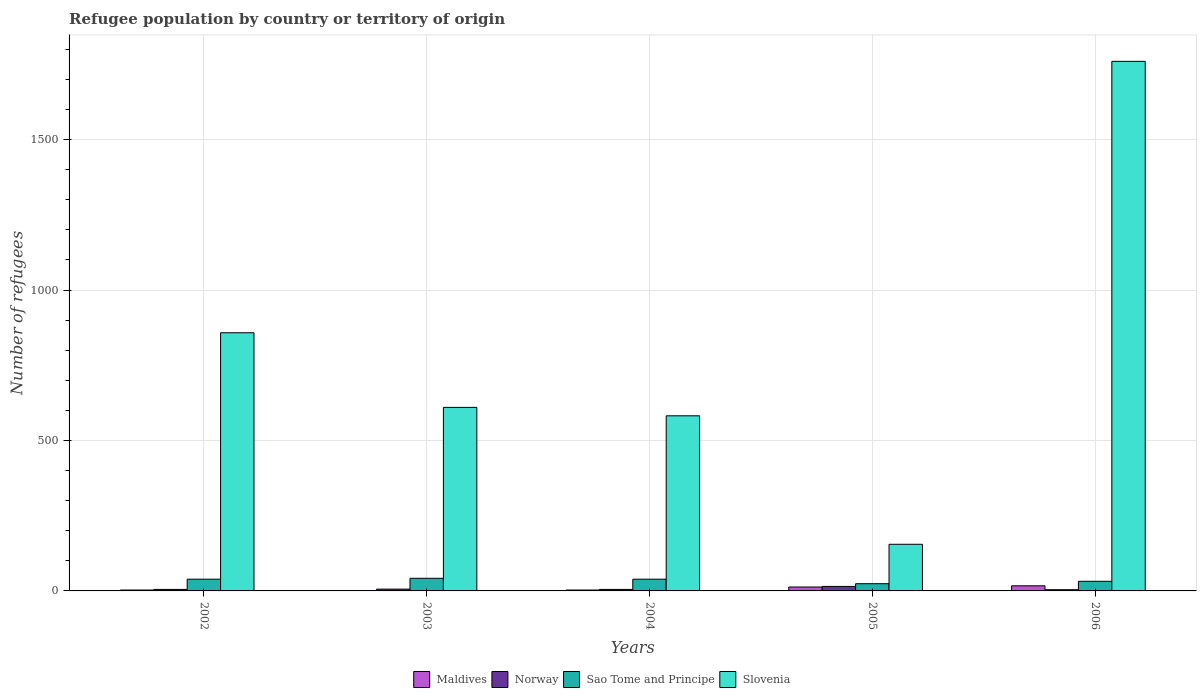How many groups of bars are there?
Offer a terse response. 5. Are the number of bars per tick equal to the number of legend labels?
Your answer should be very brief. Yes. Are the number of bars on each tick of the X-axis equal?
Provide a short and direct response. Yes. How many bars are there on the 5th tick from the left?
Offer a very short reply. 4. How many bars are there on the 5th tick from the right?
Ensure brevity in your answer.  4. In how many cases, is the number of bars for a given year not equal to the number of legend labels?
Offer a terse response. 0. What is the number of refugees in Maldives in 2005?
Give a very brief answer. 13. Across all years, what is the maximum number of refugees in Slovenia?
Provide a short and direct response. 1760. Across all years, what is the minimum number of refugees in Slovenia?
Keep it short and to the point. 155. In which year was the number of refugees in Maldives maximum?
Your answer should be compact. 2006. What is the total number of refugees in Slovenia in the graph?
Provide a succinct answer. 3965. What is the difference between the number of refugees in Slovenia in 2005 and the number of refugees in Sao Tome and Principe in 2003?
Offer a very short reply. 113. What is the average number of refugees in Maldives per year?
Provide a succinct answer. 7.4. In the year 2003, what is the difference between the number of refugees in Norway and number of refugees in Sao Tome and Principe?
Keep it short and to the point. -36. Is the difference between the number of refugees in Norway in 2002 and 2004 greater than the difference between the number of refugees in Sao Tome and Principe in 2002 and 2004?
Give a very brief answer. No. What is the difference between the highest and the lowest number of refugees in Maldives?
Ensure brevity in your answer.  16. What does the 2nd bar from the left in 2006 represents?
Your response must be concise. Norway. What does the 2nd bar from the right in 2004 represents?
Your answer should be compact. Sao Tome and Principe. Are all the bars in the graph horizontal?
Offer a very short reply. No. What is the difference between two consecutive major ticks on the Y-axis?
Provide a short and direct response. 500. Where does the legend appear in the graph?
Your response must be concise. Bottom center. How are the legend labels stacked?
Make the answer very short. Horizontal. What is the title of the graph?
Provide a succinct answer. Refugee population by country or territory of origin. Does "Australia" appear as one of the legend labels in the graph?
Offer a very short reply. No. What is the label or title of the Y-axis?
Provide a succinct answer. Number of refugees. What is the Number of refugees in Norway in 2002?
Ensure brevity in your answer.  5. What is the Number of refugees in Sao Tome and Principe in 2002?
Provide a short and direct response. 39. What is the Number of refugees in Slovenia in 2002?
Make the answer very short. 858. What is the Number of refugees of Norway in 2003?
Ensure brevity in your answer.  6. What is the Number of refugees in Slovenia in 2003?
Give a very brief answer. 610. What is the Number of refugees in Slovenia in 2004?
Give a very brief answer. 582. What is the Number of refugees of Norway in 2005?
Ensure brevity in your answer.  15. What is the Number of refugees of Slovenia in 2005?
Your answer should be very brief. 155. What is the Number of refugees in Norway in 2006?
Your answer should be very brief. 4. What is the Number of refugees of Slovenia in 2006?
Provide a short and direct response. 1760. Across all years, what is the maximum Number of refugees of Maldives?
Keep it short and to the point. 17. Across all years, what is the maximum Number of refugees in Norway?
Your answer should be very brief. 15. Across all years, what is the maximum Number of refugees in Slovenia?
Your response must be concise. 1760. Across all years, what is the minimum Number of refugees of Maldives?
Offer a very short reply. 1. Across all years, what is the minimum Number of refugees in Sao Tome and Principe?
Ensure brevity in your answer.  24. Across all years, what is the minimum Number of refugees in Slovenia?
Give a very brief answer. 155. What is the total Number of refugees of Sao Tome and Principe in the graph?
Keep it short and to the point. 176. What is the total Number of refugees in Slovenia in the graph?
Ensure brevity in your answer.  3965. What is the difference between the Number of refugees of Norway in 2002 and that in 2003?
Make the answer very short. -1. What is the difference between the Number of refugees of Slovenia in 2002 and that in 2003?
Offer a very short reply. 248. What is the difference between the Number of refugees of Maldives in 2002 and that in 2004?
Your response must be concise. 0. What is the difference between the Number of refugees in Sao Tome and Principe in 2002 and that in 2004?
Your answer should be very brief. 0. What is the difference between the Number of refugees of Slovenia in 2002 and that in 2004?
Offer a terse response. 276. What is the difference between the Number of refugees in Sao Tome and Principe in 2002 and that in 2005?
Give a very brief answer. 15. What is the difference between the Number of refugees of Slovenia in 2002 and that in 2005?
Your answer should be compact. 703. What is the difference between the Number of refugees in Maldives in 2002 and that in 2006?
Offer a terse response. -14. What is the difference between the Number of refugees of Slovenia in 2002 and that in 2006?
Offer a terse response. -902. What is the difference between the Number of refugees in Norway in 2003 and that in 2004?
Your response must be concise. 1. What is the difference between the Number of refugees of Sao Tome and Principe in 2003 and that in 2004?
Ensure brevity in your answer.  3. What is the difference between the Number of refugees in Slovenia in 2003 and that in 2004?
Provide a short and direct response. 28. What is the difference between the Number of refugees in Maldives in 2003 and that in 2005?
Provide a short and direct response. -12. What is the difference between the Number of refugees in Slovenia in 2003 and that in 2005?
Provide a short and direct response. 455. What is the difference between the Number of refugees in Maldives in 2003 and that in 2006?
Provide a succinct answer. -16. What is the difference between the Number of refugees of Norway in 2003 and that in 2006?
Ensure brevity in your answer.  2. What is the difference between the Number of refugees in Sao Tome and Principe in 2003 and that in 2006?
Keep it short and to the point. 10. What is the difference between the Number of refugees in Slovenia in 2003 and that in 2006?
Make the answer very short. -1150. What is the difference between the Number of refugees of Norway in 2004 and that in 2005?
Offer a terse response. -10. What is the difference between the Number of refugees in Slovenia in 2004 and that in 2005?
Provide a short and direct response. 427. What is the difference between the Number of refugees of Sao Tome and Principe in 2004 and that in 2006?
Ensure brevity in your answer.  7. What is the difference between the Number of refugees in Slovenia in 2004 and that in 2006?
Your answer should be very brief. -1178. What is the difference between the Number of refugees of Slovenia in 2005 and that in 2006?
Make the answer very short. -1605. What is the difference between the Number of refugees in Maldives in 2002 and the Number of refugees in Sao Tome and Principe in 2003?
Keep it short and to the point. -39. What is the difference between the Number of refugees of Maldives in 2002 and the Number of refugees of Slovenia in 2003?
Give a very brief answer. -607. What is the difference between the Number of refugees in Norway in 2002 and the Number of refugees in Sao Tome and Principe in 2003?
Provide a short and direct response. -37. What is the difference between the Number of refugees of Norway in 2002 and the Number of refugees of Slovenia in 2003?
Offer a terse response. -605. What is the difference between the Number of refugees of Sao Tome and Principe in 2002 and the Number of refugees of Slovenia in 2003?
Provide a succinct answer. -571. What is the difference between the Number of refugees in Maldives in 2002 and the Number of refugees in Norway in 2004?
Keep it short and to the point. -2. What is the difference between the Number of refugees of Maldives in 2002 and the Number of refugees of Sao Tome and Principe in 2004?
Keep it short and to the point. -36. What is the difference between the Number of refugees in Maldives in 2002 and the Number of refugees in Slovenia in 2004?
Your response must be concise. -579. What is the difference between the Number of refugees in Norway in 2002 and the Number of refugees in Sao Tome and Principe in 2004?
Make the answer very short. -34. What is the difference between the Number of refugees in Norway in 2002 and the Number of refugees in Slovenia in 2004?
Offer a very short reply. -577. What is the difference between the Number of refugees of Sao Tome and Principe in 2002 and the Number of refugees of Slovenia in 2004?
Make the answer very short. -543. What is the difference between the Number of refugees in Maldives in 2002 and the Number of refugees in Norway in 2005?
Ensure brevity in your answer.  -12. What is the difference between the Number of refugees of Maldives in 2002 and the Number of refugees of Slovenia in 2005?
Ensure brevity in your answer.  -152. What is the difference between the Number of refugees in Norway in 2002 and the Number of refugees in Slovenia in 2005?
Your answer should be very brief. -150. What is the difference between the Number of refugees of Sao Tome and Principe in 2002 and the Number of refugees of Slovenia in 2005?
Provide a short and direct response. -116. What is the difference between the Number of refugees in Maldives in 2002 and the Number of refugees in Sao Tome and Principe in 2006?
Offer a terse response. -29. What is the difference between the Number of refugees in Maldives in 2002 and the Number of refugees in Slovenia in 2006?
Provide a short and direct response. -1757. What is the difference between the Number of refugees in Norway in 2002 and the Number of refugees in Slovenia in 2006?
Offer a terse response. -1755. What is the difference between the Number of refugees in Sao Tome and Principe in 2002 and the Number of refugees in Slovenia in 2006?
Ensure brevity in your answer.  -1721. What is the difference between the Number of refugees of Maldives in 2003 and the Number of refugees of Sao Tome and Principe in 2004?
Offer a very short reply. -38. What is the difference between the Number of refugees of Maldives in 2003 and the Number of refugees of Slovenia in 2004?
Offer a terse response. -581. What is the difference between the Number of refugees of Norway in 2003 and the Number of refugees of Sao Tome and Principe in 2004?
Your response must be concise. -33. What is the difference between the Number of refugees in Norway in 2003 and the Number of refugees in Slovenia in 2004?
Offer a terse response. -576. What is the difference between the Number of refugees in Sao Tome and Principe in 2003 and the Number of refugees in Slovenia in 2004?
Ensure brevity in your answer.  -540. What is the difference between the Number of refugees in Maldives in 2003 and the Number of refugees in Norway in 2005?
Your answer should be compact. -14. What is the difference between the Number of refugees of Maldives in 2003 and the Number of refugees of Slovenia in 2005?
Provide a short and direct response. -154. What is the difference between the Number of refugees of Norway in 2003 and the Number of refugees of Sao Tome and Principe in 2005?
Make the answer very short. -18. What is the difference between the Number of refugees of Norway in 2003 and the Number of refugees of Slovenia in 2005?
Provide a succinct answer. -149. What is the difference between the Number of refugees in Sao Tome and Principe in 2003 and the Number of refugees in Slovenia in 2005?
Offer a terse response. -113. What is the difference between the Number of refugees in Maldives in 2003 and the Number of refugees in Norway in 2006?
Your answer should be compact. -3. What is the difference between the Number of refugees of Maldives in 2003 and the Number of refugees of Sao Tome and Principe in 2006?
Provide a succinct answer. -31. What is the difference between the Number of refugees of Maldives in 2003 and the Number of refugees of Slovenia in 2006?
Offer a very short reply. -1759. What is the difference between the Number of refugees in Norway in 2003 and the Number of refugees in Sao Tome and Principe in 2006?
Offer a terse response. -26. What is the difference between the Number of refugees in Norway in 2003 and the Number of refugees in Slovenia in 2006?
Provide a succinct answer. -1754. What is the difference between the Number of refugees in Sao Tome and Principe in 2003 and the Number of refugees in Slovenia in 2006?
Your answer should be compact. -1718. What is the difference between the Number of refugees of Maldives in 2004 and the Number of refugees of Norway in 2005?
Your answer should be very brief. -12. What is the difference between the Number of refugees in Maldives in 2004 and the Number of refugees in Slovenia in 2005?
Provide a short and direct response. -152. What is the difference between the Number of refugees of Norway in 2004 and the Number of refugees of Sao Tome and Principe in 2005?
Give a very brief answer. -19. What is the difference between the Number of refugees of Norway in 2004 and the Number of refugees of Slovenia in 2005?
Provide a short and direct response. -150. What is the difference between the Number of refugees in Sao Tome and Principe in 2004 and the Number of refugees in Slovenia in 2005?
Ensure brevity in your answer.  -116. What is the difference between the Number of refugees of Maldives in 2004 and the Number of refugees of Norway in 2006?
Give a very brief answer. -1. What is the difference between the Number of refugees in Maldives in 2004 and the Number of refugees in Sao Tome and Principe in 2006?
Keep it short and to the point. -29. What is the difference between the Number of refugees in Maldives in 2004 and the Number of refugees in Slovenia in 2006?
Ensure brevity in your answer.  -1757. What is the difference between the Number of refugees in Norway in 2004 and the Number of refugees in Slovenia in 2006?
Your answer should be compact. -1755. What is the difference between the Number of refugees of Sao Tome and Principe in 2004 and the Number of refugees of Slovenia in 2006?
Provide a succinct answer. -1721. What is the difference between the Number of refugees of Maldives in 2005 and the Number of refugees of Norway in 2006?
Make the answer very short. 9. What is the difference between the Number of refugees of Maldives in 2005 and the Number of refugees of Slovenia in 2006?
Keep it short and to the point. -1747. What is the difference between the Number of refugees in Norway in 2005 and the Number of refugees in Slovenia in 2006?
Keep it short and to the point. -1745. What is the difference between the Number of refugees in Sao Tome and Principe in 2005 and the Number of refugees in Slovenia in 2006?
Your answer should be compact. -1736. What is the average Number of refugees in Sao Tome and Principe per year?
Your response must be concise. 35.2. What is the average Number of refugees in Slovenia per year?
Your answer should be compact. 793. In the year 2002, what is the difference between the Number of refugees of Maldives and Number of refugees of Norway?
Offer a very short reply. -2. In the year 2002, what is the difference between the Number of refugees in Maldives and Number of refugees in Sao Tome and Principe?
Give a very brief answer. -36. In the year 2002, what is the difference between the Number of refugees in Maldives and Number of refugees in Slovenia?
Your response must be concise. -855. In the year 2002, what is the difference between the Number of refugees in Norway and Number of refugees in Sao Tome and Principe?
Offer a terse response. -34. In the year 2002, what is the difference between the Number of refugees of Norway and Number of refugees of Slovenia?
Your answer should be compact. -853. In the year 2002, what is the difference between the Number of refugees in Sao Tome and Principe and Number of refugees in Slovenia?
Your answer should be very brief. -819. In the year 2003, what is the difference between the Number of refugees in Maldives and Number of refugees in Sao Tome and Principe?
Give a very brief answer. -41. In the year 2003, what is the difference between the Number of refugees in Maldives and Number of refugees in Slovenia?
Keep it short and to the point. -609. In the year 2003, what is the difference between the Number of refugees in Norway and Number of refugees in Sao Tome and Principe?
Offer a terse response. -36. In the year 2003, what is the difference between the Number of refugees in Norway and Number of refugees in Slovenia?
Make the answer very short. -604. In the year 2003, what is the difference between the Number of refugees of Sao Tome and Principe and Number of refugees of Slovenia?
Provide a succinct answer. -568. In the year 2004, what is the difference between the Number of refugees of Maldives and Number of refugees of Sao Tome and Principe?
Your response must be concise. -36. In the year 2004, what is the difference between the Number of refugees of Maldives and Number of refugees of Slovenia?
Provide a short and direct response. -579. In the year 2004, what is the difference between the Number of refugees of Norway and Number of refugees of Sao Tome and Principe?
Provide a succinct answer. -34. In the year 2004, what is the difference between the Number of refugees in Norway and Number of refugees in Slovenia?
Provide a short and direct response. -577. In the year 2004, what is the difference between the Number of refugees of Sao Tome and Principe and Number of refugees of Slovenia?
Provide a short and direct response. -543. In the year 2005, what is the difference between the Number of refugees in Maldives and Number of refugees in Norway?
Your response must be concise. -2. In the year 2005, what is the difference between the Number of refugees of Maldives and Number of refugees of Sao Tome and Principe?
Provide a short and direct response. -11. In the year 2005, what is the difference between the Number of refugees in Maldives and Number of refugees in Slovenia?
Provide a succinct answer. -142. In the year 2005, what is the difference between the Number of refugees in Norway and Number of refugees in Sao Tome and Principe?
Make the answer very short. -9. In the year 2005, what is the difference between the Number of refugees of Norway and Number of refugees of Slovenia?
Provide a succinct answer. -140. In the year 2005, what is the difference between the Number of refugees of Sao Tome and Principe and Number of refugees of Slovenia?
Offer a very short reply. -131. In the year 2006, what is the difference between the Number of refugees of Maldives and Number of refugees of Slovenia?
Your answer should be very brief. -1743. In the year 2006, what is the difference between the Number of refugees of Norway and Number of refugees of Slovenia?
Make the answer very short. -1756. In the year 2006, what is the difference between the Number of refugees of Sao Tome and Principe and Number of refugees of Slovenia?
Your answer should be very brief. -1728. What is the ratio of the Number of refugees of Maldives in 2002 to that in 2003?
Your answer should be very brief. 3. What is the ratio of the Number of refugees of Norway in 2002 to that in 2003?
Your answer should be compact. 0.83. What is the ratio of the Number of refugees of Slovenia in 2002 to that in 2003?
Your answer should be very brief. 1.41. What is the ratio of the Number of refugees in Maldives in 2002 to that in 2004?
Provide a short and direct response. 1. What is the ratio of the Number of refugees in Sao Tome and Principe in 2002 to that in 2004?
Provide a succinct answer. 1. What is the ratio of the Number of refugees of Slovenia in 2002 to that in 2004?
Your answer should be very brief. 1.47. What is the ratio of the Number of refugees of Maldives in 2002 to that in 2005?
Keep it short and to the point. 0.23. What is the ratio of the Number of refugees of Sao Tome and Principe in 2002 to that in 2005?
Offer a terse response. 1.62. What is the ratio of the Number of refugees of Slovenia in 2002 to that in 2005?
Offer a very short reply. 5.54. What is the ratio of the Number of refugees in Maldives in 2002 to that in 2006?
Give a very brief answer. 0.18. What is the ratio of the Number of refugees of Sao Tome and Principe in 2002 to that in 2006?
Your response must be concise. 1.22. What is the ratio of the Number of refugees of Slovenia in 2002 to that in 2006?
Your answer should be compact. 0.49. What is the ratio of the Number of refugees in Norway in 2003 to that in 2004?
Ensure brevity in your answer.  1.2. What is the ratio of the Number of refugees in Sao Tome and Principe in 2003 to that in 2004?
Ensure brevity in your answer.  1.08. What is the ratio of the Number of refugees of Slovenia in 2003 to that in 2004?
Your response must be concise. 1.05. What is the ratio of the Number of refugees in Maldives in 2003 to that in 2005?
Offer a very short reply. 0.08. What is the ratio of the Number of refugees of Norway in 2003 to that in 2005?
Offer a terse response. 0.4. What is the ratio of the Number of refugees in Slovenia in 2003 to that in 2005?
Make the answer very short. 3.94. What is the ratio of the Number of refugees in Maldives in 2003 to that in 2006?
Offer a terse response. 0.06. What is the ratio of the Number of refugees in Sao Tome and Principe in 2003 to that in 2006?
Make the answer very short. 1.31. What is the ratio of the Number of refugees in Slovenia in 2003 to that in 2006?
Make the answer very short. 0.35. What is the ratio of the Number of refugees in Maldives in 2004 to that in 2005?
Offer a very short reply. 0.23. What is the ratio of the Number of refugees in Sao Tome and Principe in 2004 to that in 2005?
Provide a succinct answer. 1.62. What is the ratio of the Number of refugees in Slovenia in 2004 to that in 2005?
Ensure brevity in your answer.  3.75. What is the ratio of the Number of refugees of Maldives in 2004 to that in 2006?
Keep it short and to the point. 0.18. What is the ratio of the Number of refugees of Norway in 2004 to that in 2006?
Offer a very short reply. 1.25. What is the ratio of the Number of refugees in Sao Tome and Principe in 2004 to that in 2006?
Provide a succinct answer. 1.22. What is the ratio of the Number of refugees of Slovenia in 2004 to that in 2006?
Your response must be concise. 0.33. What is the ratio of the Number of refugees in Maldives in 2005 to that in 2006?
Provide a short and direct response. 0.76. What is the ratio of the Number of refugees in Norway in 2005 to that in 2006?
Your answer should be very brief. 3.75. What is the ratio of the Number of refugees of Slovenia in 2005 to that in 2006?
Offer a very short reply. 0.09. What is the difference between the highest and the second highest Number of refugees of Norway?
Make the answer very short. 9. What is the difference between the highest and the second highest Number of refugees of Slovenia?
Give a very brief answer. 902. What is the difference between the highest and the lowest Number of refugees in Maldives?
Your response must be concise. 16. What is the difference between the highest and the lowest Number of refugees in Sao Tome and Principe?
Provide a succinct answer. 18. What is the difference between the highest and the lowest Number of refugees in Slovenia?
Provide a short and direct response. 1605. 